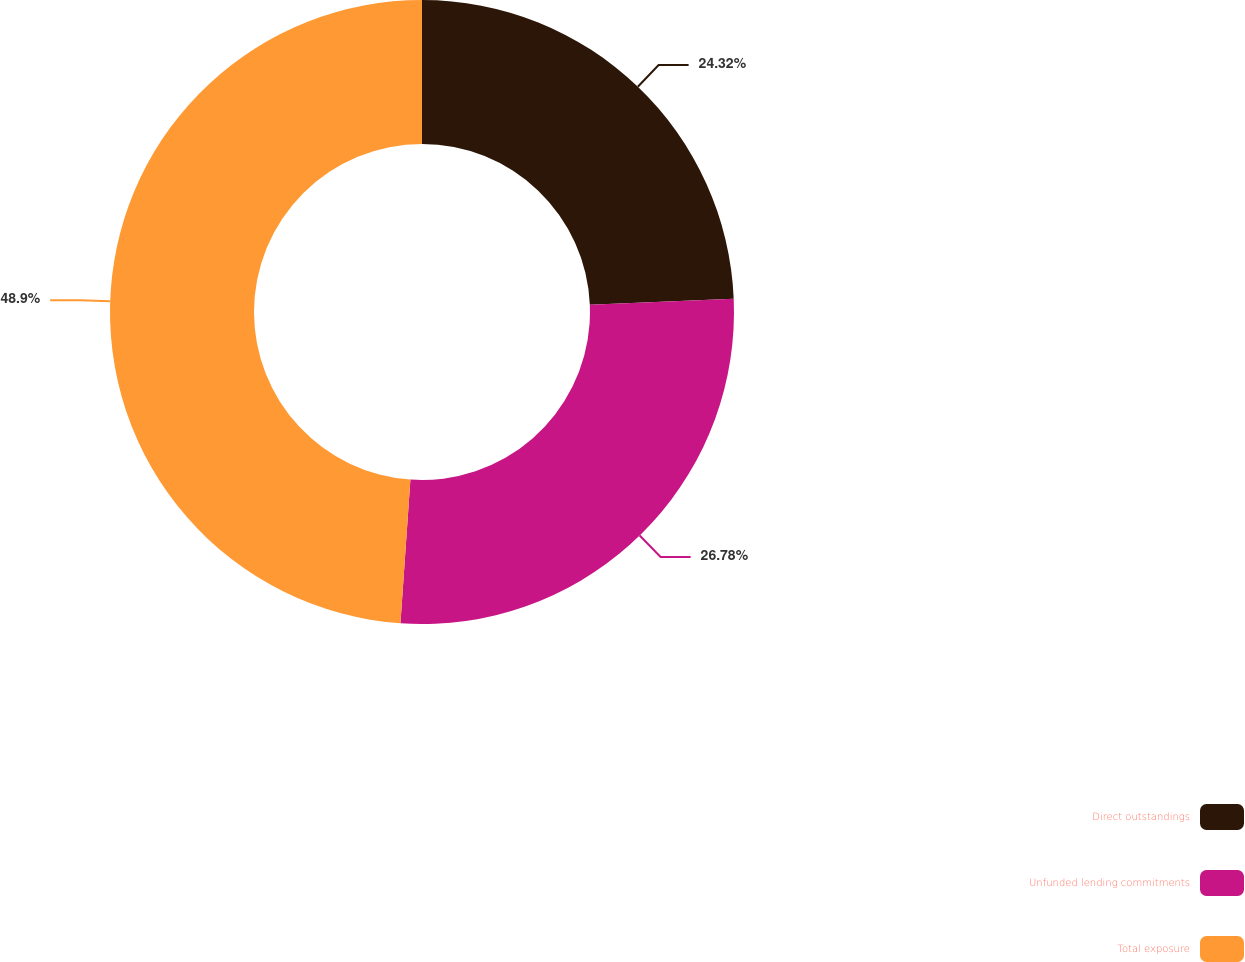Convert chart. <chart><loc_0><loc_0><loc_500><loc_500><pie_chart><fcel>Direct outstandings<fcel>Unfunded lending commitments<fcel>Total exposure<nl><fcel>24.32%<fcel>26.78%<fcel>48.9%<nl></chart> 